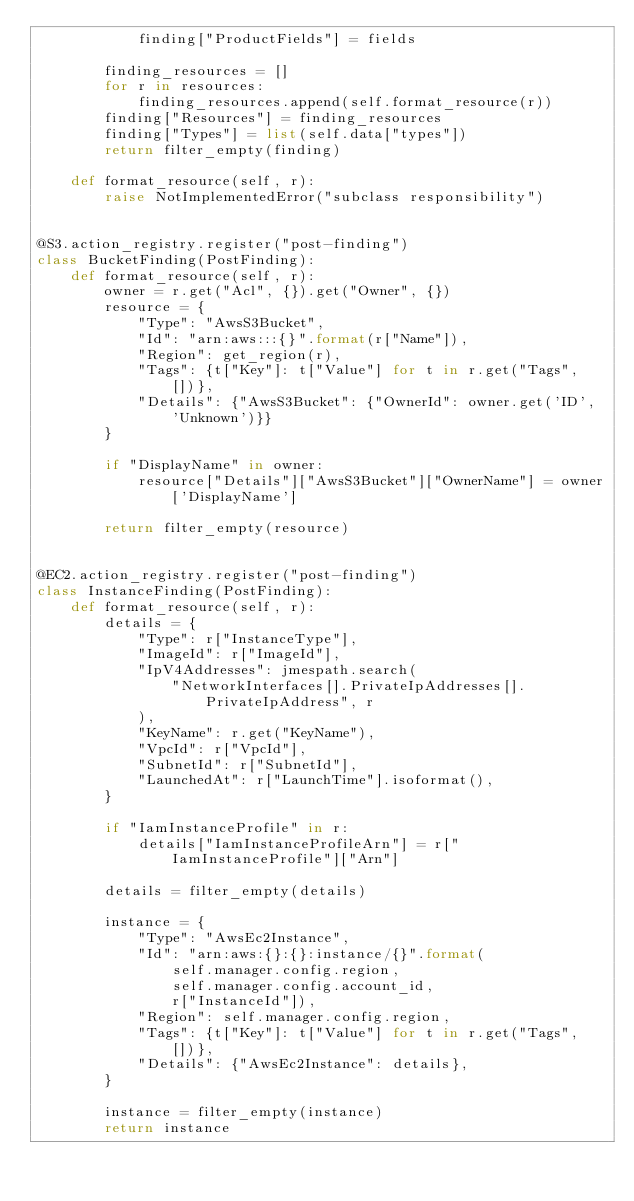<code> <loc_0><loc_0><loc_500><loc_500><_Python_>            finding["ProductFields"] = fields

        finding_resources = []
        for r in resources:
            finding_resources.append(self.format_resource(r))
        finding["Resources"] = finding_resources
        finding["Types"] = list(self.data["types"])
        return filter_empty(finding)

    def format_resource(self, r):
        raise NotImplementedError("subclass responsibility")


@S3.action_registry.register("post-finding")
class BucketFinding(PostFinding):
    def format_resource(self, r):
        owner = r.get("Acl", {}).get("Owner", {})
        resource = {
            "Type": "AwsS3Bucket",
            "Id": "arn:aws:::{}".format(r["Name"]),
            "Region": get_region(r),
            "Tags": {t["Key"]: t["Value"] for t in r.get("Tags", [])},
            "Details": {"AwsS3Bucket": {"OwnerId": owner.get('ID', 'Unknown')}}
        }

        if "DisplayName" in owner:
            resource["Details"]["AwsS3Bucket"]["OwnerName"] = owner['DisplayName']

        return filter_empty(resource)


@EC2.action_registry.register("post-finding")
class InstanceFinding(PostFinding):
    def format_resource(self, r):
        details = {
            "Type": r["InstanceType"],
            "ImageId": r["ImageId"],
            "IpV4Addresses": jmespath.search(
                "NetworkInterfaces[].PrivateIpAddresses[].PrivateIpAddress", r
            ),
            "KeyName": r.get("KeyName"),
            "VpcId": r["VpcId"],
            "SubnetId": r["SubnetId"],
            "LaunchedAt": r["LaunchTime"].isoformat(),
        }

        if "IamInstanceProfile" in r:
            details["IamInstanceProfileArn"] = r["IamInstanceProfile"]["Arn"]

        details = filter_empty(details)

        instance = {
            "Type": "AwsEc2Instance",
            "Id": "arn:aws:{}:{}:instance/{}".format(
                self.manager.config.region,
                self.manager.config.account_id,
                r["InstanceId"]),
            "Region": self.manager.config.region,
            "Tags": {t["Key"]: t["Value"] for t in r.get("Tags", [])},
            "Details": {"AwsEc2Instance": details},
        }

        instance = filter_empty(instance)
        return instance
</code> 